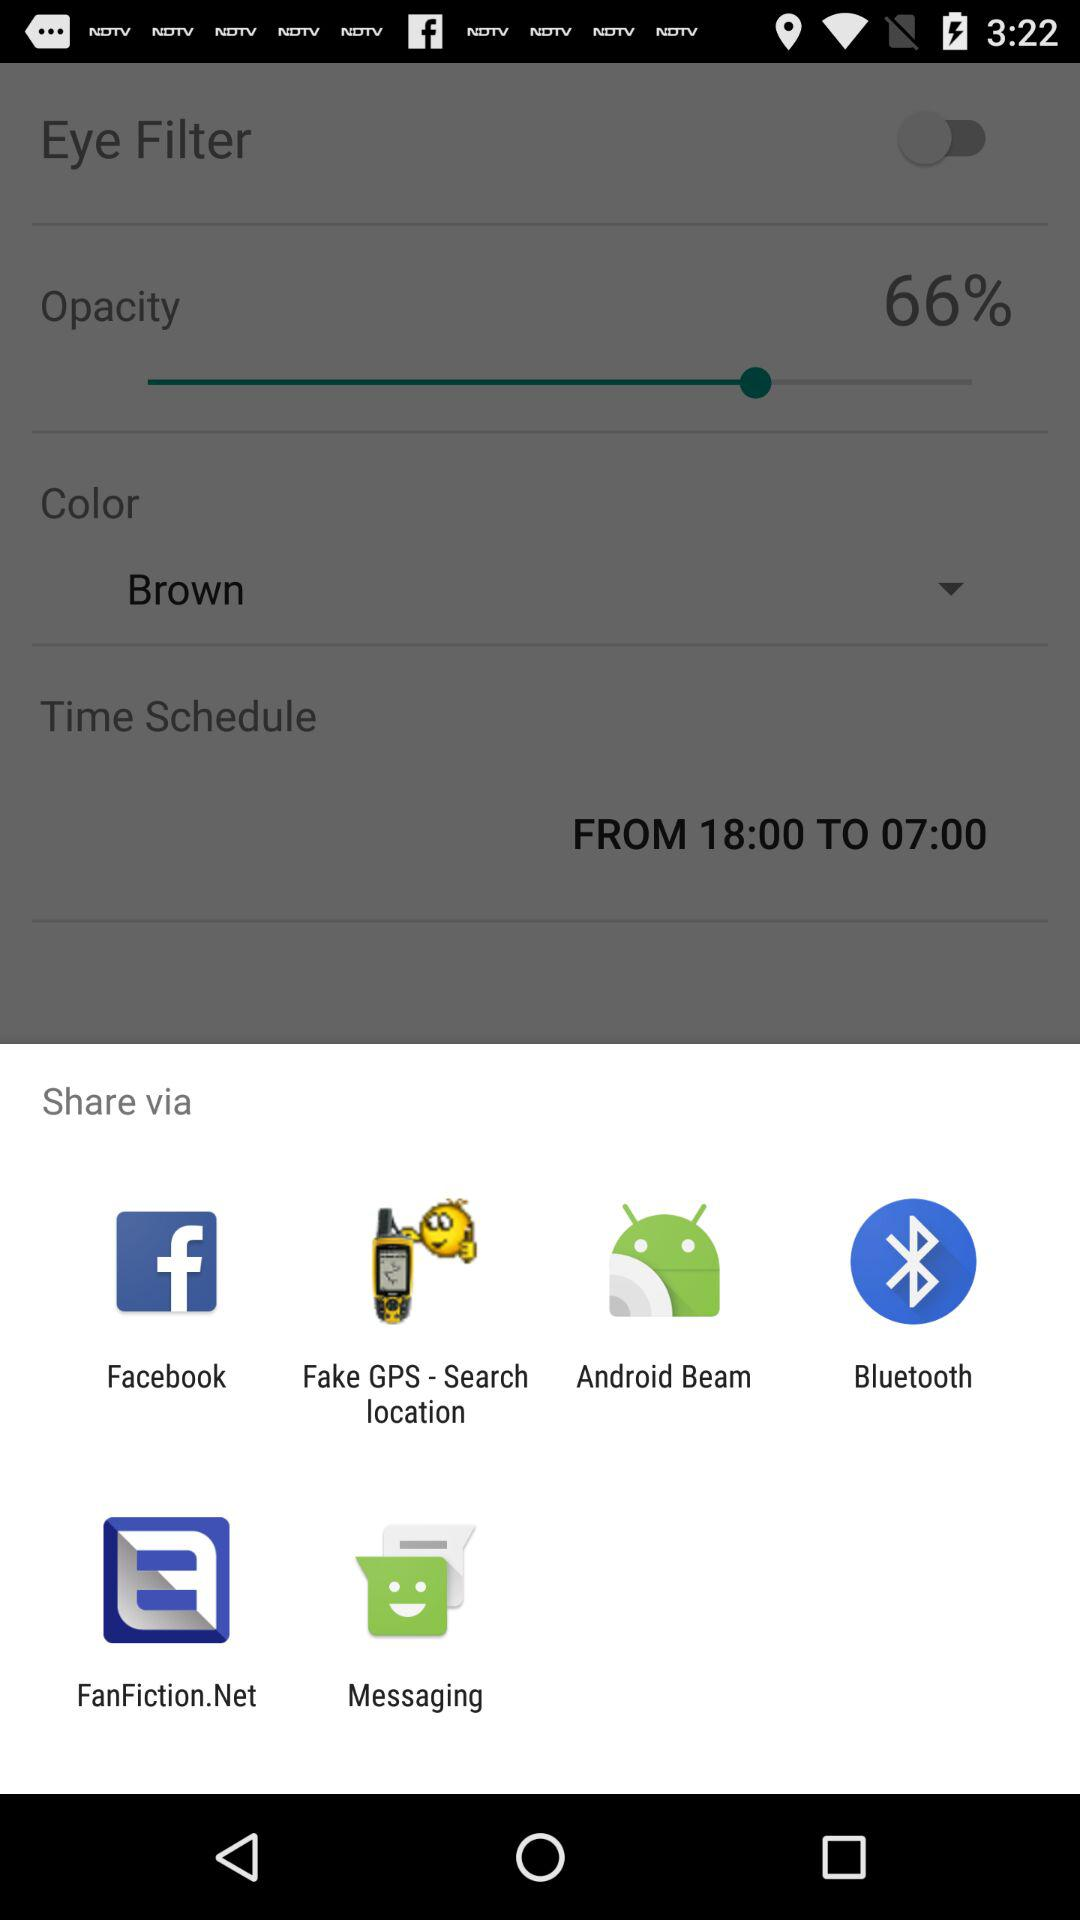What is the scheduled date?
When the provided information is insufficient, respond with <no answer>. <no answer> 